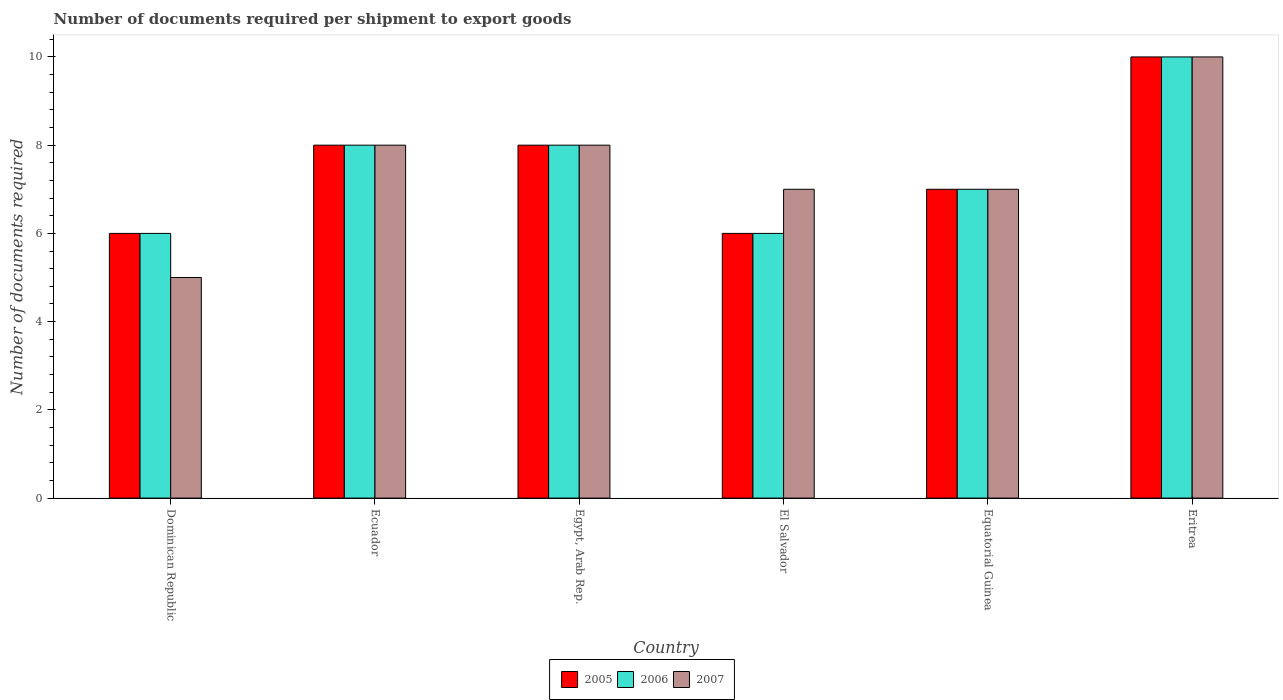Are the number of bars on each tick of the X-axis equal?
Your answer should be compact. Yes. What is the label of the 3rd group of bars from the left?
Make the answer very short. Egypt, Arab Rep. In how many cases, is the number of bars for a given country not equal to the number of legend labels?
Make the answer very short. 0. Across all countries, what is the maximum number of documents required per shipment to export goods in 2005?
Your response must be concise. 10. Across all countries, what is the minimum number of documents required per shipment to export goods in 2007?
Your response must be concise. 5. In which country was the number of documents required per shipment to export goods in 2007 maximum?
Your answer should be compact. Eritrea. In which country was the number of documents required per shipment to export goods in 2007 minimum?
Provide a succinct answer. Dominican Republic. What is the difference between the number of documents required per shipment to export goods in 2006 in El Salvador and that in Eritrea?
Keep it short and to the point. -4. What is the difference between the number of documents required per shipment to export goods in 2005 in Eritrea and the number of documents required per shipment to export goods in 2007 in Ecuador?
Provide a short and direct response. 2. What is the difference between the number of documents required per shipment to export goods of/in 2006 and number of documents required per shipment to export goods of/in 2007 in Dominican Republic?
Give a very brief answer. 1. In how many countries, is the number of documents required per shipment to export goods in 2005 greater than 4?
Offer a very short reply. 6. What is the ratio of the number of documents required per shipment to export goods in 2007 in Equatorial Guinea to that in Eritrea?
Offer a very short reply. 0.7. Is the difference between the number of documents required per shipment to export goods in 2006 in Egypt, Arab Rep. and El Salvador greater than the difference between the number of documents required per shipment to export goods in 2007 in Egypt, Arab Rep. and El Salvador?
Your response must be concise. Yes. What is the difference between the highest and the second highest number of documents required per shipment to export goods in 2006?
Offer a terse response. -2. What is the difference between the highest and the lowest number of documents required per shipment to export goods in 2005?
Provide a succinct answer. 4. In how many countries, is the number of documents required per shipment to export goods in 2006 greater than the average number of documents required per shipment to export goods in 2006 taken over all countries?
Provide a short and direct response. 3. Is it the case that in every country, the sum of the number of documents required per shipment to export goods in 2006 and number of documents required per shipment to export goods in 2005 is greater than the number of documents required per shipment to export goods in 2007?
Your response must be concise. Yes. How many bars are there?
Offer a very short reply. 18. How many countries are there in the graph?
Make the answer very short. 6. Are the values on the major ticks of Y-axis written in scientific E-notation?
Your response must be concise. No. Where does the legend appear in the graph?
Ensure brevity in your answer.  Bottom center. How are the legend labels stacked?
Provide a succinct answer. Horizontal. What is the title of the graph?
Keep it short and to the point. Number of documents required per shipment to export goods. Does "1995" appear as one of the legend labels in the graph?
Offer a very short reply. No. What is the label or title of the Y-axis?
Give a very brief answer. Number of documents required. What is the Number of documents required of 2006 in Dominican Republic?
Offer a very short reply. 6. What is the Number of documents required of 2007 in Dominican Republic?
Offer a very short reply. 5. What is the Number of documents required of 2005 in Ecuador?
Provide a short and direct response. 8. What is the Number of documents required in 2006 in Ecuador?
Provide a succinct answer. 8. What is the Number of documents required in 2007 in Ecuador?
Offer a very short reply. 8. What is the Number of documents required in 2006 in Egypt, Arab Rep.?
Provide a short and direct response. 8. What is the Number of documents required of 2007 in Egypt, Arab Rep.?
Keep it short and to the point. 8. What is the Number of documents required of 2006 in El Salvador?
Give a very brief answer. 6. What is the Number of documents required of 2005 in Equatorial Guinea?
Offer a terse response. 7. What is the Number of documents required in 2006 in Eritrea?
Offer a terse response. 10. What is the Number of documents required in 2007 in Eritrea?
Offer a very short reply. 10. Across all countries, what is the minimum Number of documents required in 2007?
Your response must be concise. 5. What is the total Number of documents required in 2005 in the graph?
Your answer should be very brief. 45. What is the total Number of documents required in 2006 in the graph?
Give a very brief answer. 45. What is the difference between the Number of documents required in 2006 in Dominican Republic and that in Egypt, Arab Rep.?
Offer a terse response. -2. What is the difference between the Number of documents required of 2007 in Dominican Republic and that in Egypt, Arab Rep.?
Your response must be concise. -3. What is the difference between the Number of documents required in 2005 in Dominican Republic and that in El Salvador?
Your response must be concise. 0. What is the difference between the Number of documents required of 2006 in Dominican Republic and that in El Salvador?
Make the answer very short. 0. What is the difference between the Number of documents required in 2005 in Dominican Republic and that in Equatorial Guinea?
Offer a very short reply. -1. What is the difference between the Number of documents required in 2005 in Ecuador and that in Egypt, Arab Rep.?
Your answer should be very brief. 0. What is the difference between the Number of documents required of 2005 in Ecuador and that in Equatorial Guinea?
Provide a short and direct response. 1. What is the difference between the Number of documents required of 2006 in Ecuador and that in Equatorial Guinea?
Ensure brevity in your answer.  1. What is the difference between the Number of documents required in 2005 in Ecuador and that in Eritrea?
Your answer should be very brief. -2. What is the difference between the Number of documents required in 2006 in Ecuador and that in Eritrea?
Keep it short and to the point. -2. What is the difference between the Number of documents required of 2007 in Ecuador and that in Eritrea?
Your answer should be very brief. -2. What is the difference between the Number of documents required of 2005 in Egypt, Arab Rep. and that in El Salvador?
Ensure brevity in your answer.  2. What is the difference between the Number of documents required in 2006 in Egypt, Arab Rep. and that in Equatorial Guinea?
Ensure brevity in your answer.  1. What is the difference between the Number of documents required in 2007 in Egypt, Arab Rep. and that in Equatorial Guinea?
Ensure brevity in your answer.  1. What is the difference between the Number of documents required of 2005 in Egypt, Arab Rep. and that in Eritrea?
Your response must be concise. -2. What is the difference between the Number of documents required in 2007 in Egypt, Arab Rep. and that in Eritrea?
Your response must be concise. -2. What is the difference between the Number of documents required of 2006 in El Salvador and that in Equatorial Guinea?
Ensure brevity in your answer.  -1. What is the difference between the Number of documents required of 2007 in El Salvador and that in Equatorial Guinea?
Your response must be concise. 0. What is the difference between the Number of documents required in 2006 in El Salvador and that in Eritrea?
Make the answer very short. -4. What is the difference between the Number of documents required in 2005 in Dominican Republic and the Number of documents required in 2006 in Ecuador?
Your answer should be very brief. -2. What is the difference between the Number of documents required in 2006 in Dominican Republic and the Number of documents required in 2007 in Ecuador?
Ensure brevity in your answer.  -2. What is the difference between the Number of documents required in 2005 in Dominican Republic and the Number of documents required in 2006 in Egypt, Arab Rep.?
Offer a terse response. -2. What is the difference between the Number of documents required of 2005 in Dominican Republic and the Number of documents required of 2007 in Egypt, Arab Rep.?
Make the answer very short. -2. What is the difference between the Number of documents required of 2006 in Dominican Republic and the Number of documents required of 2007 in Egypt, Arab Rep.?
Your answer should be very brief. -2. What is the difference between the Number of documents required in 2005 in Dominican Republic and the Number of documents required in 2007 in El Salvador?
Offer a very short reply. -1. What is the difference between the Number of documents required of 2006 in Dominican Republic and the Number of documents required of 2007 in El Salvador?
Provide a short and direct response. -1. What is the difference between the Number of documents required of 2006 in Dominican Republic and the Number of documents required of 2007 in Equatorial Guinea?
Offer a terse response. -1. What is the difference between the Number of documents required of 2005 in Dominican Republic and the Number of documents required of 2006 in Eritrea?
Make the answer very short. -4. What is the difference between the Number of documents required of 2006 in Dominican Republic and the Number of documents required of 2007 in Eritrea?
Keep it short and to the point. -4. What is the difference between the Number of documents required of 2006 in Ecuador and the Number of documents required of 2007 in Egypt, Arab Rep.?
Provide a succinct answer. 0. What is the difference between the Number of documents required of 2005 in Ecuador and the Number of documents required of 2006 in El Salvador?
Provide a short and direct response. 2. What is the difference between the Number of documents required in 2006 in Ecuador and the Number of documents required in 2007 in El Salvador?
Provide a succinct answer. 1. What is the difference between the Number of documents required of 2005 in Ecuador and the Number of documents required of 2007 in Equatorial Guinea?
Your response must be concise. 1. What is the difference between the Number of documents required of 2006 in Ecuador and the Number of documents required of 2007 in Equatorial Guinea?
Your response must be concise. 1. What is the difference between the Number of documents required of 2005 in Ecuador and the Number of documents required of 2006 in Eritrea?
Provide a short and direct response. -2. What is the difference between the Number of documents required in 2005 in Ecuador and the Number of documents required in 2007 in Eritrea?
Your answer should be very brief. -2. What is the difference between the Number of documents required in 2005 in Egypt, Arab Rep. and the Number of documents required in 2006 in El Salvador?
Provide a succinct answer. 2. What is the difference between the Number of documents required of 2006 in Egypt, Arab Rep. and the Number of documents required of 2007 in El Salvador?
Your answer should be compact. 1. What is the difference between the Number of documents required in 2005 in Egypt, Arab Rep. and the Number of documents required in 2007 in Equatorial Guinea?
Your answer should be compact. 1. What is the difference between the Number of documents required of 2005 in Egypt, Arab Rep. and the Number of documents required of 2007 in Eritrea?
Your answer should be very brief. -2. What is the difference between the Number of documents required in 2005 in El Salvador and the Number of documents required in 2006 in Eritrea?
Your answer should be very brief. -4. What is the difference between the Number of documents required of 2005 and Number of documents required of 2006 in Dominican Republic?
Give a very brief answer. 0. What is the difference between the Number of documents required in 2005 and Number of documents required in 2007 in Dominican Republic?
Keep it short and to the point. 1. What is the difference between the Number of documents required of 2005 and Number of documents required of 2006 in Ecuador?
Ensure brevity in your answer.  0. What is the difference between the Number of documents required in 2005 and Number of documents required in 2006 in El Salvador?
Offer a very short reply. 0. What is the difference between the Number of documents required in 2005 and Number of documents required in 2007 in El Salvador?
Provide a short and direct response. -1. What is the difference between the Number of documents required of 2006 and Number of documents required of 2007 in El Salvador?
Provide a short and direct response. -1. What is the difference between the Number of documents required in 2005 and Number of documents required in 2006 in Equatorial Guinea?
Your answer should be compact. 0. What is the difference between the Number of documents required of 2005 and Number of documents required of 2007 in Equatorial Guinea?
Ensure brevity in your answer.  0. What is the difference between the Number of documents required in 2006 and Number of documents required in 2007 in Equatorial Guinea?
Provide a succinct answer. 0. What is the difference between the Number of documents required of 2005 and Number of documents required of 2006 in Eritrea?
Provide a short and direct response. 0. What is the difference between the Number of documents required of 2005 and Number of documents required of 2007 in Eritrea?
Your response must be concise. 0. What is the ratio of the Number of documents required in 2007 in Dominican Republic to that in Egypt, Arab Rep.?
Offer a very short reply. 0.62. What is the ratio of the Number of documents required in 2005 in Dominican Republic to that in El Salvador?
Offer a very short reply. 1. What is the ratio of the Number of documents required of 2005 in Dominican Republic to that in Equatorial Guinea?
Offer a terse response. 0.86. What is the ratio of the Number of documents required of 2006 in Dominican Republic to that in Equatorial Guinea?
Provide a short and direct response. 0.86. What is the ratio of the Number of documents required of 2007 in Dominican Republic to that in Equatorial Guinea?
Your answer should be compact. 0.71. What is the ratio of the Number of documents required in 2006 in Dominican Republic to that in Eritrea?
Your response must be concise. 0.6. What is the ratio of the Number of documents required in 2007 in Dominican Republic to that in Eritrea?
Provide a short and direct response. 0.5. What is the ratio of the Number of documents required of 2006 in Ecuador to that in Egypt, Arab Rep.?
Provide a short and direct response. 1. What is the ratio of the Number of documents required in 2007 in Ecuador to that in Egypt, Arab Rep.?
Your answer should be very brief. 1. What is the ratio of the Number of documents required in 2005 in Ecuador to that in El Salvador?
Your response must be concise. 1.33. What is the ratio of the Number of documents required in 2006 in Ecuador to that in El Salvador?
Make the answer very short. 1.33. What is the ratio of the Number of documents required of 2006 in Ecuador to that in Equatorial Guinea?
Your answer should be compact. 1.14. What is the ratio of the Number of documents required in 2007 in Ecuador to that in Equatorial Guinea?
Your answer should be very brief. 1.14. What is the ratio of the Number of documents required of 2006 in Egypt, Arab Rep. to that in El Salvador?
Make the answer very short. 1.33. What is the ratio of the Number of documents required of 2007 in Egypt, Arab Rep. to that in Equatorial Guinea?
Make the answer very short. 1.14. What is the ratio of the Number of documents required in 2005 in Egypt, Arab Rep. to that in Eritrea?
Provide a short and direct response. 0.8. What is the ratio of the Number of documents required of 2006 in Egypt, Arab Rep. to that in Eritrea?
Offer a terse response. 0.8. What is the ratio of the Number of documents required in 2005 in El Salvador to that in Equatorial Guinea?
Offer a terse response. 0.86. What is the ratio of the Number of documents required in 2007 in El Salvador to that in Equatorial Guinea?
Offer a very short reply. 1. What is the ratio of the Number of documents required in 2006 in El Salvador to that in Eritrea?
Provide a short and direct response. 0.6. What is the ratio of the Number of documents required in 2007 in El Salvador to that in Eritrea?
Your answer should be compact. 0.7. What is the ratio of the Number of documents required in 2005 in Equatorial Guinea to that in Eritrea?
Provide a short and direct response. 0.7. What is the ratio of the Number of documents required of 2007 in Equatorial Guinea to that in Eritrea?
Your response must be concise. 0.7. What is the difference between the highest and the second highest Number of documents required in 2006?
Provide a short and direct response. 2. What is the difference between the highest and the lowest Number of documents required of 2006?
Ensure brevity in your answer.  4. 